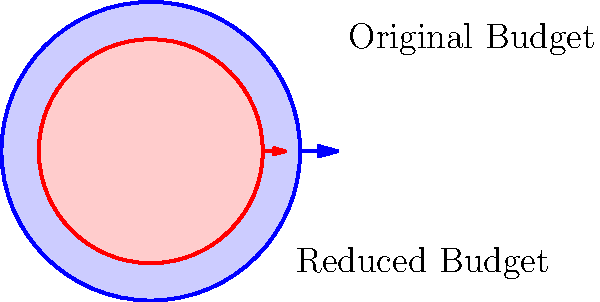The image shows two concentric circles representing budget sizes. If the area of the outer circle represents the original budget of $100 million, what is the approximate value of the reduced budget represented by the inner circle? To solve this problem, we need to follow these steps:

1. Recognize that the areas of the circles are proportional to the budget amounts.

2. Calculate the ratio of the areas of the inner and outer circles:
   Let $r$ be the radius of the outer circle and $x$ be the radius of the inner circle.
   Area ratio = $\frac{\pi x^2}{\pi r^2} = \frac{x^2}{r^2}$

3. From the image, we can see that the radius of the inner circle is 3/4 of the outer circle:
   $x = \frac{3}{4}r$

4. Substitute this into the area ratio:
   Area ratio = $\frac{(\frac{3}{4}r)^2}{r^2} = \frac{9}{16} = 0.5625$

5. The reduced budget is this fraction of the original budget:
   Reduced budget = $0.5625 \times 100$ million = $56.25$ million

Therefore, the reduced budget is approximately $56.25 million.
Answer: $56.25 million 